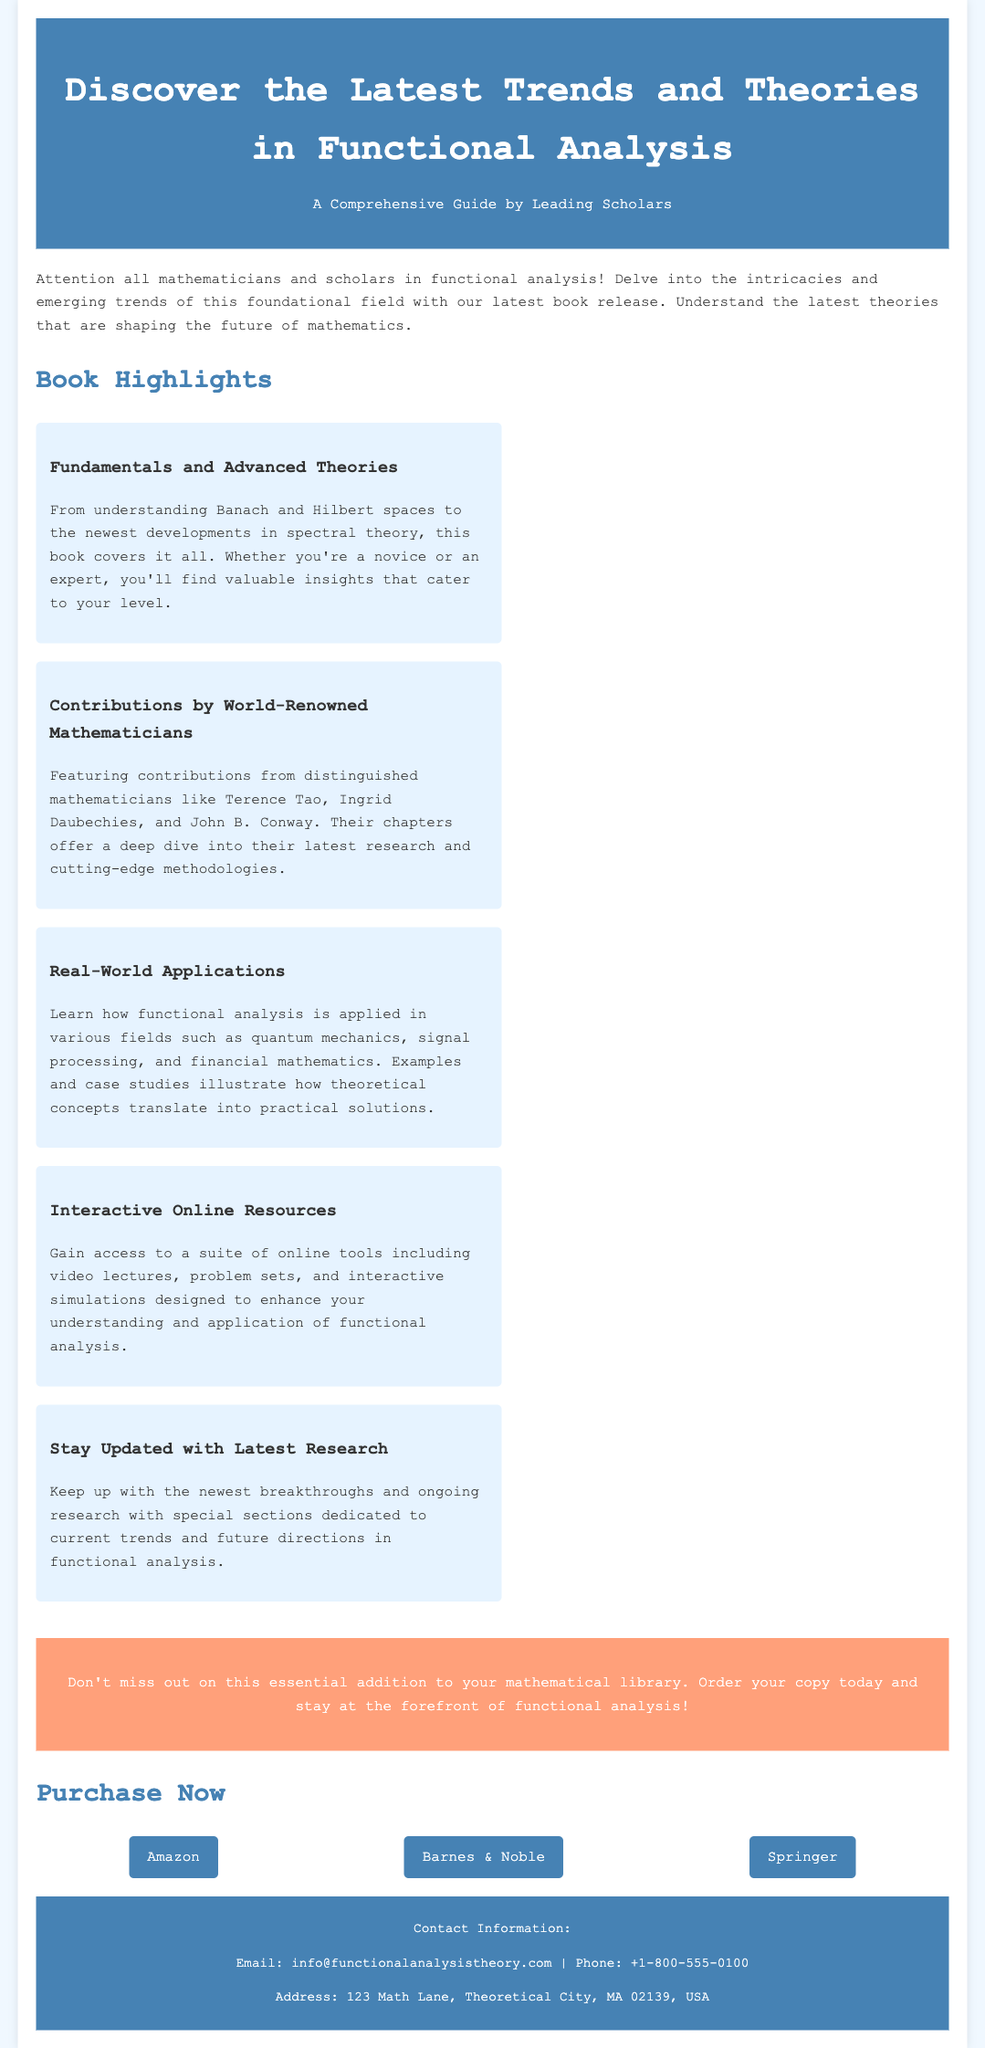What is the title of the book? The title of the book is presented prominently in the document as the main subject of the advertisement.
Answer: Latest Trends and Theories in Functional Analysis Who are some of the mathematicians contributing to the book? The document lists prominent mathematicians involved in the project, highlighting their contributions to the field.
Answer: Terence Tao, Ingrid Daubechies, John B. Conway What kind of online resources does the book provide? The advertisement mentions a type of resource offered to enhance understanding of functional analysis, which suggests interactivity.
Answer: Interactive Online Resources What is one application of functional analysis mentioned in the document? The text specifies various fields where functional analysis is applied, providing a tangible example.
Answer: Quantum mechanics How many highlights are presented in the document? The highlights section outlines significant features of the book, and their count is an important piece of information for potential readers.
Answer: Five highlights What is the call to action in the advertisement? The document contains a statement urging readers to take an action related to the book, which is typical in advertisements.
Answer: Order your copy today What are the purchase platforms listed in the document? The advertisement directs potential purchasers to specific platforms where the book can be obtained, which is essential for readers looking to acquire it.
Answer: Amazon, Barnes & Noble, Springer What is the color scheme of the header? The header's color scheme is important for the visual appeal and branding of the advertisement.
Answer: Blue and white What type of document is this? The overall structure and content of the document indicate its purpose and classification.
Answer: Advertisement 